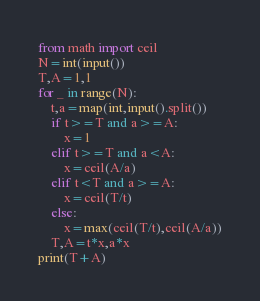Convert code to text. <code><loc_0><loc_0><loc_500><loc_500><_Python_>from math import ceil
N=int(input())
T,A=1,1
for _ in range(N):
    t,a=map(int,input().split())
    if t>=T and a>=A:
        x=1
    elif t>=T and a<A:
        x=ceil(A/a)
    elif t<T and a>=A:
        x=ceil(T/t)
    else:
        x=max(ceil(T/t),ceil(A/a))
    T,A=t*x,a*x
print(T+A)</code> 